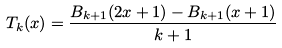Convert formula to latex. <formula><loc_0><loc_0><loc_500><loc_500>T _ { k } ( x ) = \frac { B _ { k + 1 } ( 2 x + 1 ) - B _ { k + 1 } ( x + 1 ) } { k + 1 }</formula> 